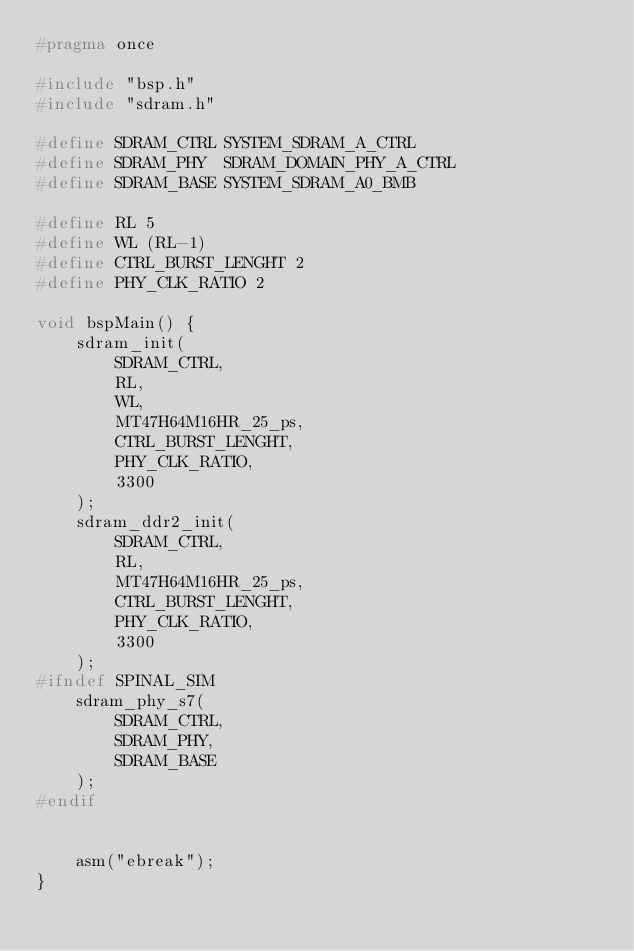<code> <loc_0><loc_0><loc_500><loc_500><_C_>#pragma once

#include "bsp.h"
#include "sdram.h"

#define SDRAM_CTRL SYSTEM_SDRAM_A_CTRL
#define SDRAM_PHY  SDRAM_DOMAIN_PHY_A_CTRL
#define SDRAM_BASE SYSTEM_SDRAM_A0_BMB

#define RL 5
#define WL (RL-1)
#define CTRL_BURST_LENGHT 2
#define PHY_CLK_RATIO 2

void bspMain() {
    sdram_init(
        SDRAM_CTRL,
        RL,
        WL,
        MT47H64M16HR_25_ps,
        CTRL_BURST_LENGHT,
        PHY_CLK_RATIO,
        3300
    );
    sdram_ddr2_init(
        SDRAM_CTRL,
        RL,
        MT47H64M16HR_25_ps,
        CTRL_BURST_LENGHT,
        PHY_CLK_RATIO,
        3300
    );
#ifndef SPINAL_SIM
    sdram_phy_s7(
        SDRAM_CTRL,
        SDRAM_PHY,
        SDRAM_BASE
    );
#endif


    asm("ebreak");
}
</code> 